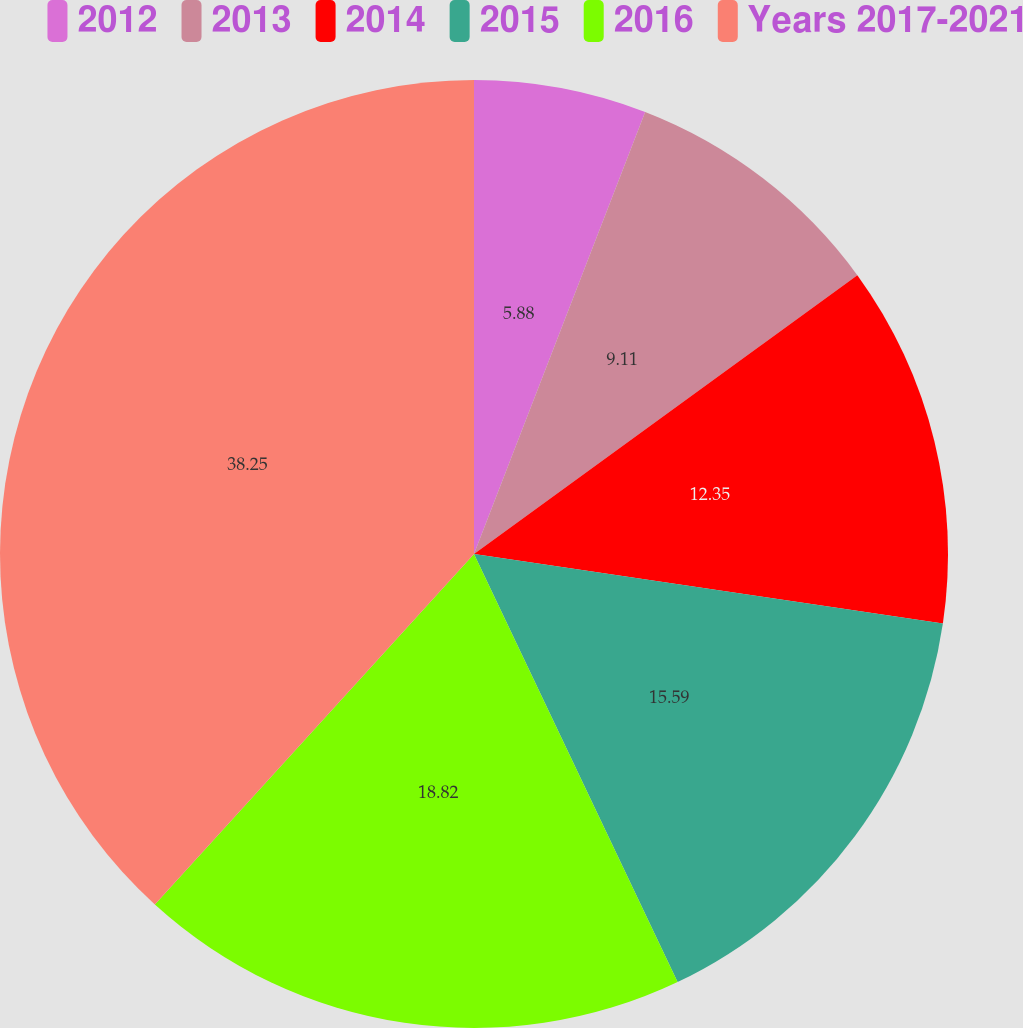<chart> <loc_0><loc_0><loc_500><loc_500><pie_chart><fcel>2012<fcel>2013<fcel>2014<fcel>2015<fcel>2016<fcel>Years 2017-2021<nl><fcel>5.88%<fcel>9.11%<fcel>12.35%<fcel>15.59%<fcel>18.82%<fcel>38.24%<nl></chart> 